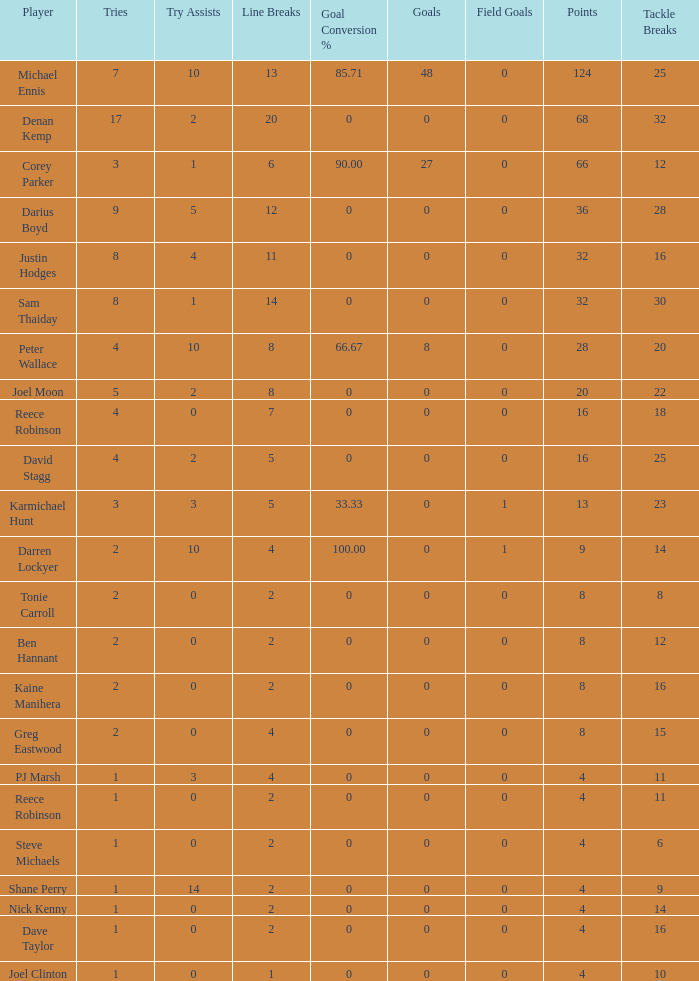How many points did the player with 2 tries and more than 0 field goals have? 9.0. 